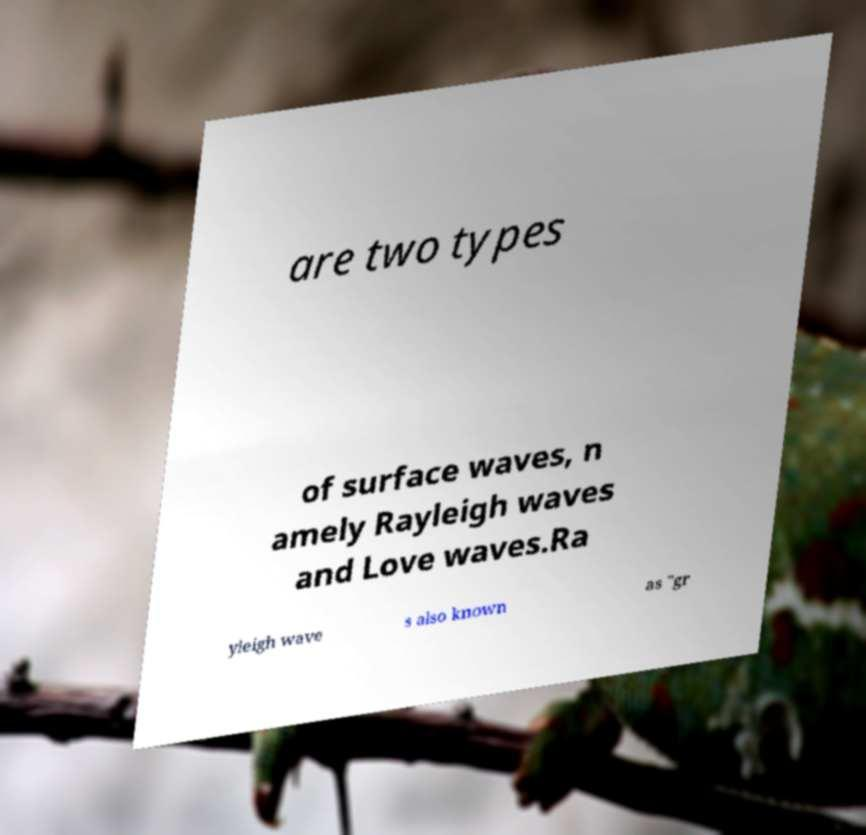I need the written content from this picture converted into text. Can you do that? are two types of surface waves, n amely Rayleigh waves and Love waves.Ra yleigh wave s also known as "gr 